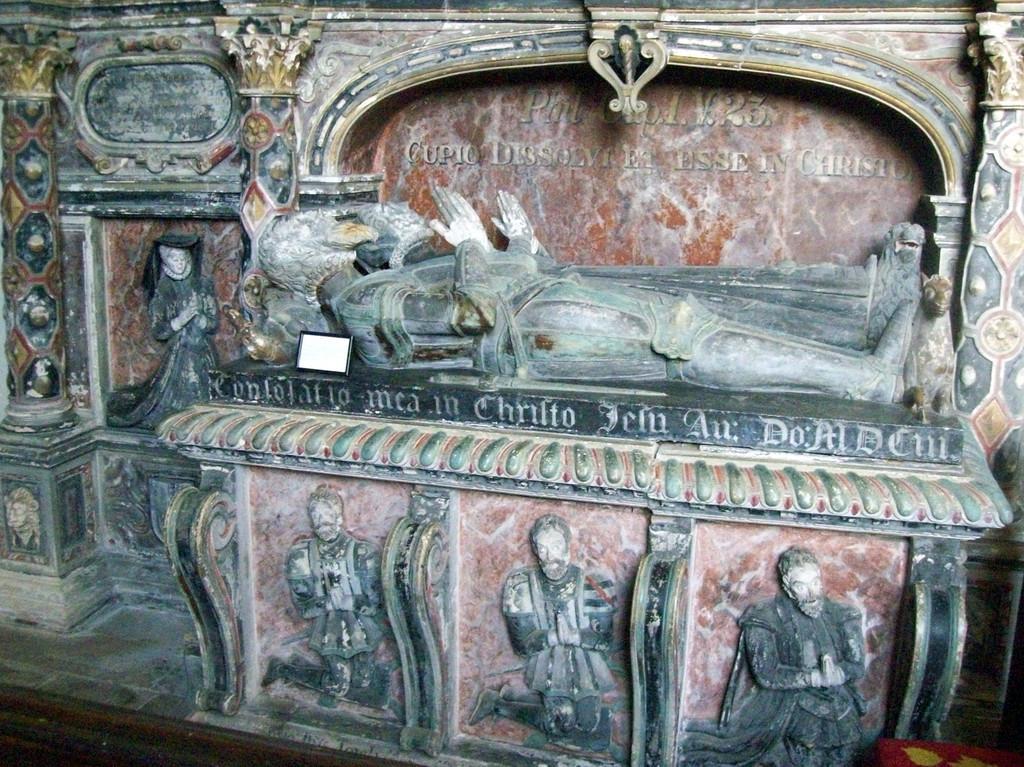Could you give a brief overview of what you see in this image? In this picture we can see some sculptures of persons here, there is some text here. 